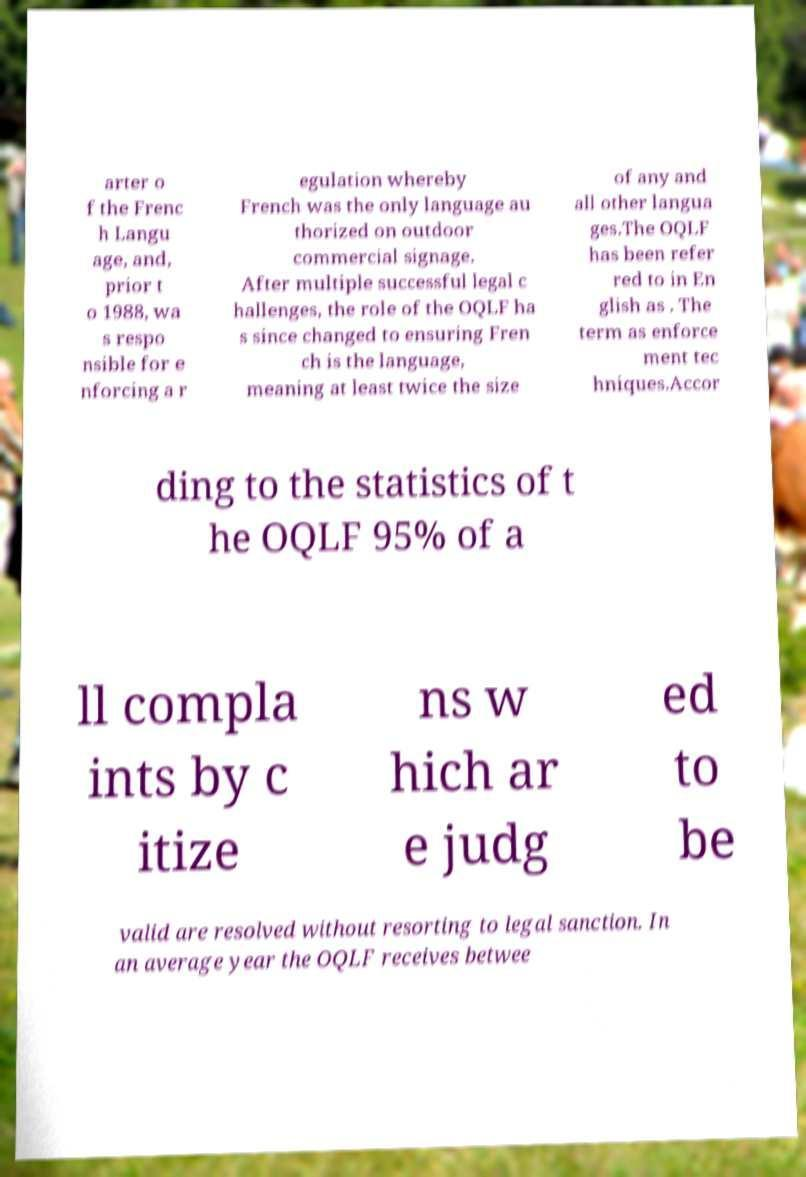Can you accurately transcribe the text from the provided image for me? arter o f the Frenc h Langu age, and, prior t o 1988, wa s respo nsible for e nforcing a r egulation whereby French was the only language au thorized on outdoor commercial signage. After multiple successful legal c hallenges, the role of the OQLF ha s since changed to ensuring Fren ch is the language, meaning at least twice the size of any and all other langua ges.The OQLF has been refer red to in En glish as . The term as enforce ment tec hniques.Accor ding to the statistics of t he OQLF 95% of a ll compla ints by c itize ns w hich ar e judg ed to be valid are resolved without resorting to legal sanction. In an average year the OQLF receives betwee 